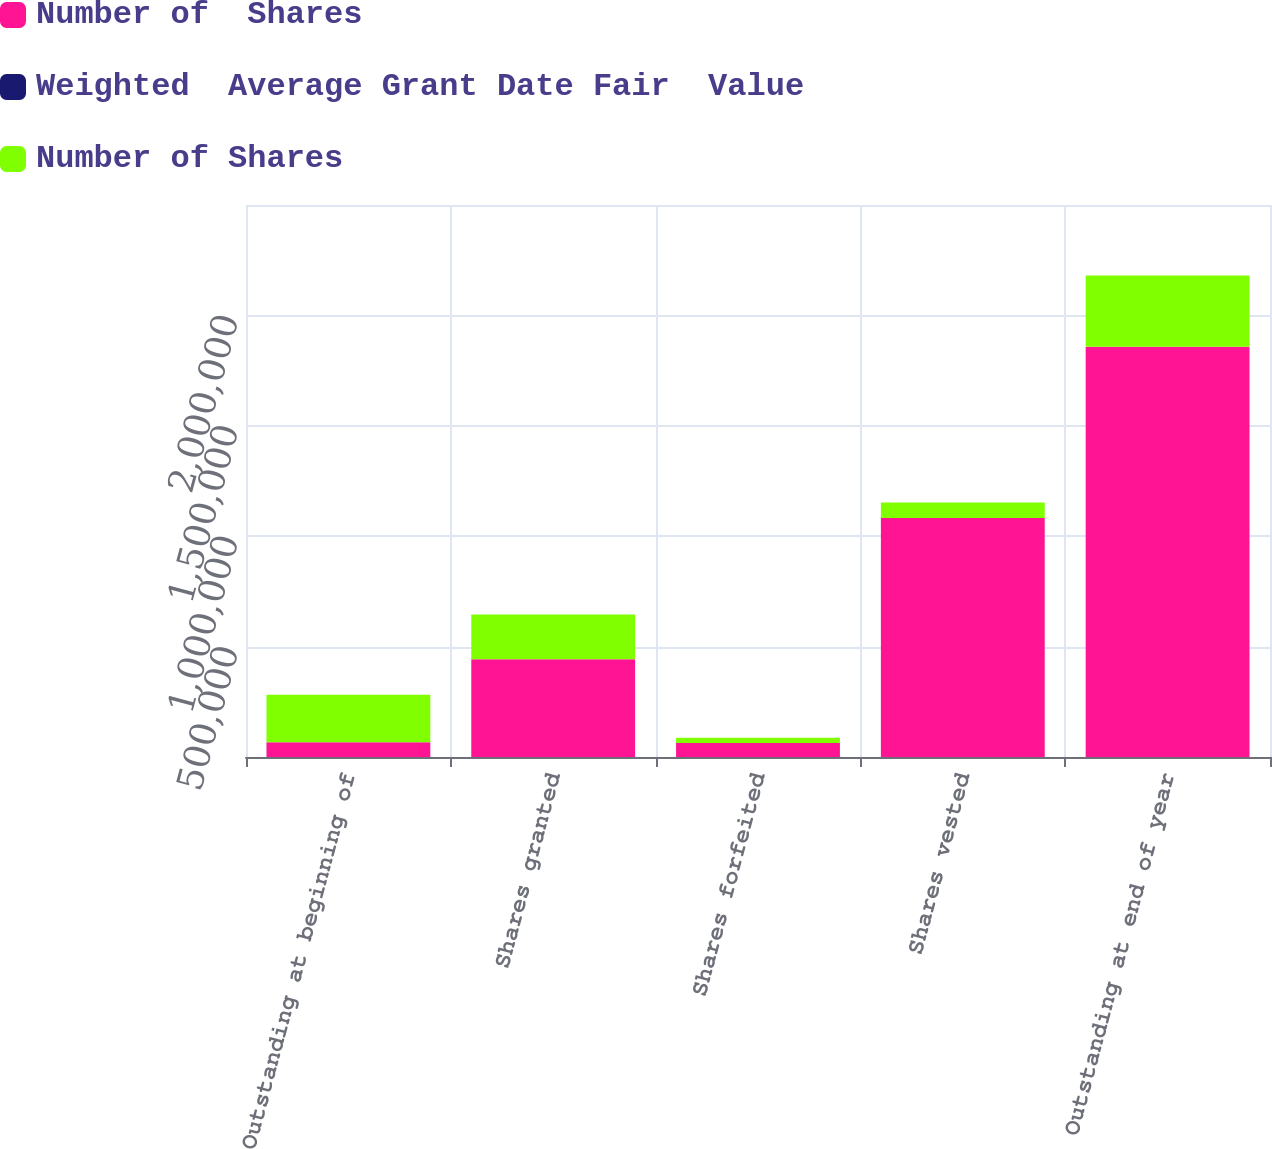Convert chart to OTSL. <chart><loc_0><loc_0><loc_500><loc_500><stacked_bar_chart><ecel><fcel>Outstanding at beginning of<fcel>Shares granted<fcel>Shares forfeited<fcel>Shares vested<fcel>Outstanding at end of year<nl><fcel>Number of  Shares<fcel>66886<fcel>443060<fcel>63105<fcel>1.08212e+06<fcel>1.85761e+06<nl><fcel>Weighted  Average Grant Date Fair  Value<fcel>28.85<fcel>97.52<fcel>54.51<fcel>36.41<fcel>39.95<nl><fcel>Number of Shares<fcel>215134<fcel>202411<fcel>23953<fcel>70667<fcel>322925<nl></chart> 